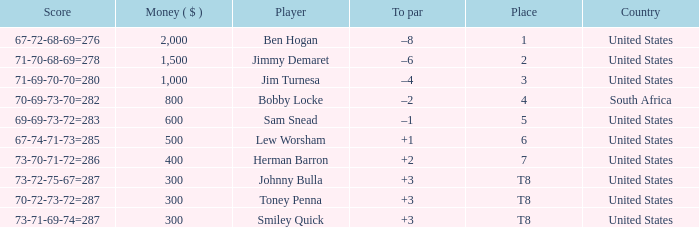For a player with a combined score of 73-70-71-72=286, what is their to par? 2.0. Would you mind parsing the complete table? {'header': ['Score', 'Money ( $ )', 'Player', 'To par', 'Place', 'Country'], 'rows': [['67-72-68-69=276', '2,000', 'Ben Hogan', '–8', '1', 'United States'], ['71-70-68-69=278', '1,500', 'Jimmy Demaret', '–6', '2', 'United States'], ['71-69-70-70=280', '1,000', 'Jim Turnesa', '–4', '3', 'United States'], ['70-69-73-70=282', '800', 'Bobby Locke', '–2', '4', 'South Africa'], ['69-69-73-72=283', '600', 'Sam Snead', '–1', '5', 'United States'], ['67-74-71-73=285', '500', 'Lew Worsham', '+1', '6', 'United States'], ['73-70-71-72=286', '400', 'Herman Barron', '+2', '7', 'United States'], ['73-72-75-67=287', '300', 'Johnny Bulla', '+3', 'T8', 'United States'], ['70-72-73-72=287', '300', 'Toney Penna', '+3', 'T8', 'United States'], ['73-71-69-74=287', '300', 'Smiley Quick', '+3', 'T8', 'United States']]} 